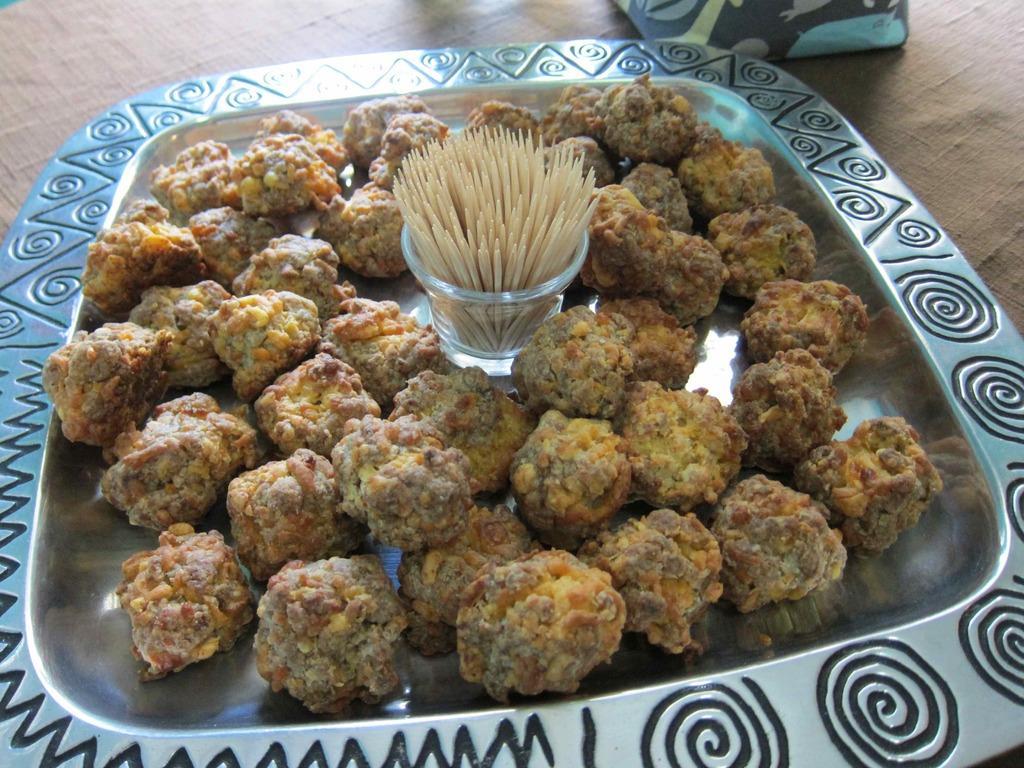How would you summarize this image in a sentence or two? In this image I can see some food in the plate. In the middle of the plate where are toothpicks. 